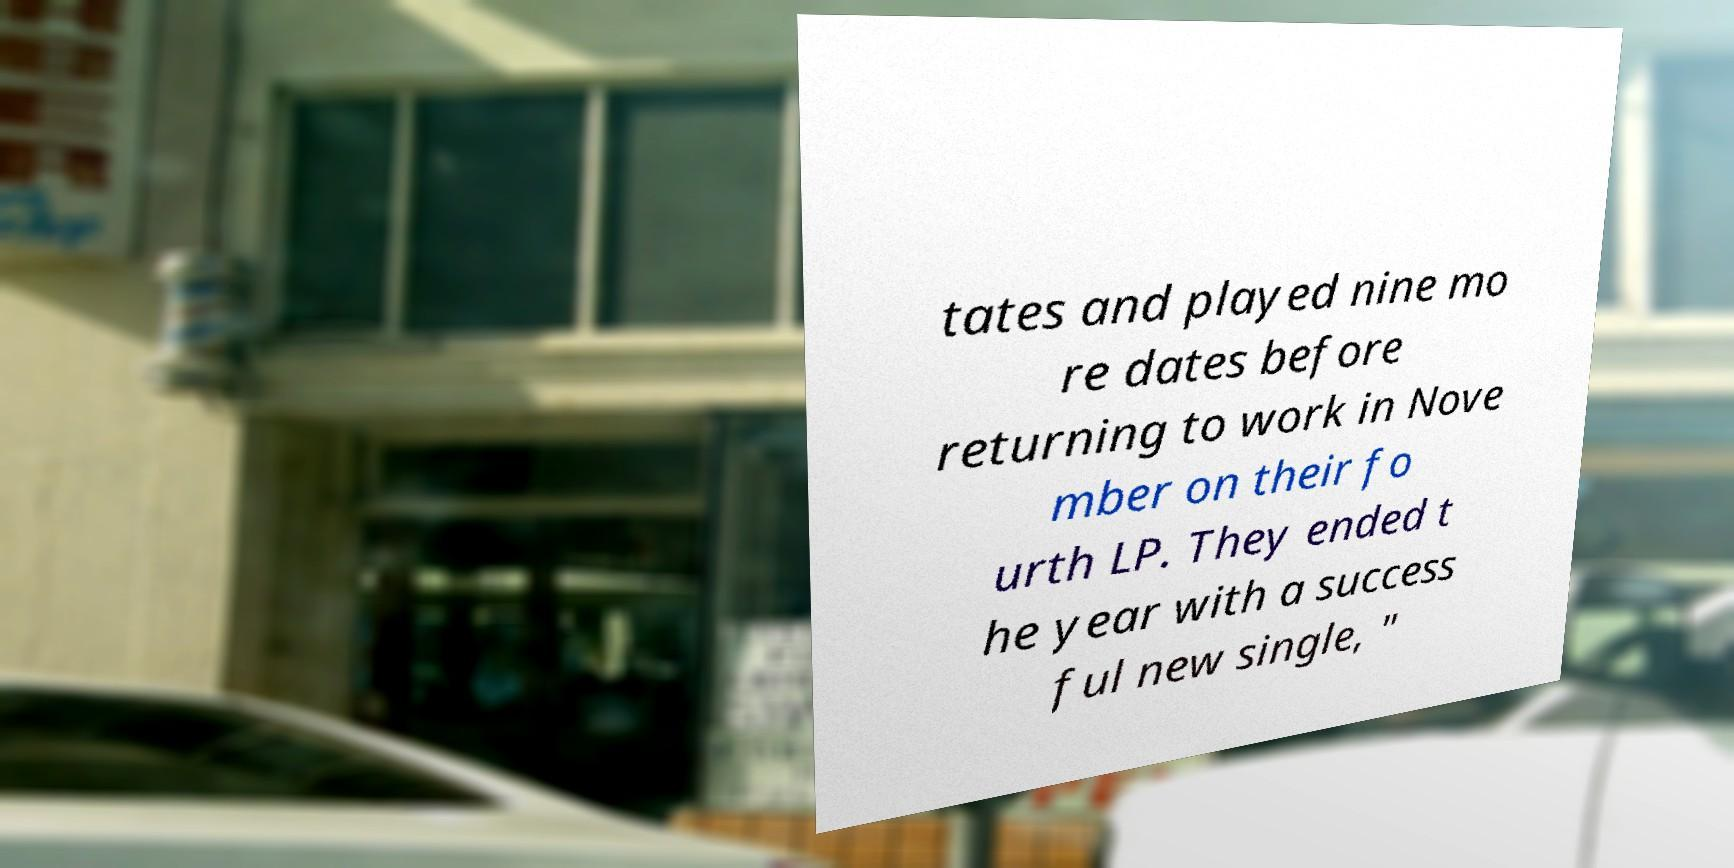Can you accurately transcribe the text from the provided image for me? tates and played nine mo re dates before returning to work in Nove mber on their fo urth LP. They ended t he year with a success ful new single, " 